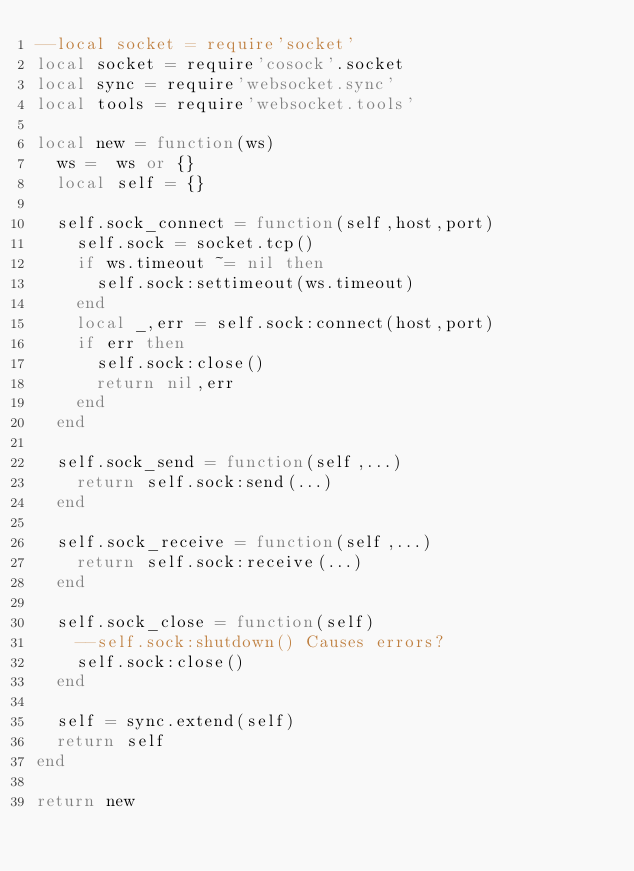Convert code to text. <code><loc_0><loc_0><loc_500><loc_500><_Lua_>--local socket = require'socket'
local socket = require'cosock'.socket
local sync = require'websocket.sync'
local tools = require'websocket.tools'

local new = function(ws)
  ws =  ws or {}
  local self = {}
  
  self.sock_connect = function(self,host,port)
    self.sock = socket.tcp()
    if ws.timeout ~= nil then
      self.sock:settimeout(ws.timeout)
    end
    local _,err = self.sock:connect(host,port)
    if err then
      self.sock:close()
      return nil,err
    end
  end
  
  self.sock_send = function(self,...)
    return self.sock:send(...)
  end
  
  self.sock_receive = function(self,...)
    return self.sock:receive(...)
  end
  
  self.sock_close = function(self)
    --self.sock:shutdown() Causes errors?
    self.sock:close()
  end
  
  self = sync.extend(self)
  return self
end

return new
</code> 